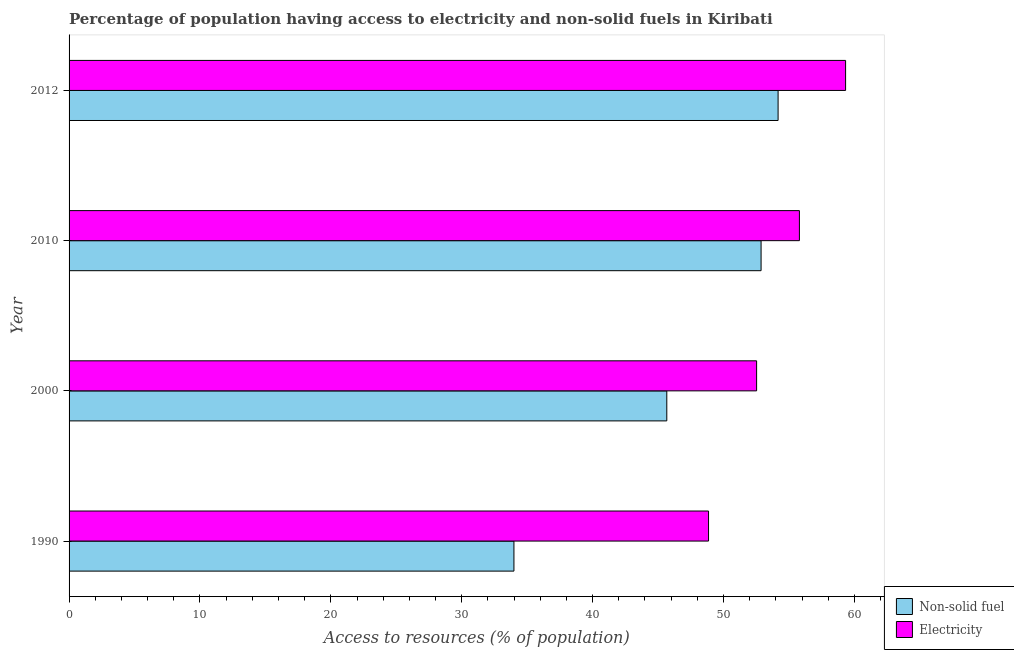How many different coloured bars are there?
Keep it short and to the point. 2. Are the number of bars on each tick of the Y-axis equal?
Ensure brevity in your answer.  Yes. How many bars are there on the 1st tick from the top?
Your response must be concise. 2. What is the label of the 2nd group of bars from the top?
Provide a succinct answer. 2010. What is the percentage of population having access to electricity in 1990?
Give a very brief answer. 48.86. Across all years, what is the maximum percentage of population having access to electricity?
Provide a short and direct response. 59.33. Across all years, what is the minimum percentage of population having access to non-solid fuel?
Your answer should be compact. 33.99. In which year was the percentage of population having access to non-solid fuel minimum?
Ensure brevity in your answer.  1990. What is the total percentage of population having access to non-solid fuel in the graph?
Provide a succinct answer. 186.7. What is the difference between the percentage of population having access to electricity in 1990 and that in 2000?
Provide a succinct answer. -3.67. What is the difference between the percentage of population having access to non-solid fuel in 2000 and the percentage of population having access to electricity in 2010?
Your response must be concise. -10.13. What is the average percentage of population having access to non-solid fuel per year?
Make the answer very short. 46.68. In the year 2012, what is the difference between the percentage of population having access to non-solid fuel and percentage of population having access to electricity?
Offer a very short reply. -5.16. What is the ratio of the percentage of population having access to electricity in 1990 to that in 2012?
Make the answer very short. 0.82. Is the difference between the percentage of population having access to electricity in 2000 and 2010 greater than the difference between the percentage of population having access to non-solid fuel in 2000 and 2010?
Provide a succinct answer. Yes. What is the difference between the highest and the second highest percentage of population having access to non-solid fuel?
Provide a short and direct response. 1.3. What is the difference between the highest and the lowest percentage of population having access to electricity?
Offer a terse response. 10.47. What does the 2nd bar from the top in 1990 represents?
Your answer should be very brief. Non-solid fuel. What does the 2nd bar from the bottom in 2010 represents?
Provide a succinct answer. Electricity. How many years are there in the graph?
Make the answer very short. 4. What is the difference between two consecutive major ticks on the X-axis?
Ensure brevity in your answer.  10. Does the graph contain any zero values?
Provide a succinct answer. No. Where does the legend appear in the graph?
Keep it short and to the point. Bottom right. How many legend labels are there?
Provide a succinct answer. 2. How are the legend labels stacked?
Your response must be concise. Vertical. What is the title of the graph?
Your response must be concise. Percentage of population having access to electricity and non-solid fuels in Kiribati. Does "% of gross capital formation" appear as one of the legend labels in the graph?
Provide a succinct answer. No. What is the label or title of the X-axis?
Give a very brief answer. Access to resources (% of population). What is the label or title of the Y-axis?
Offer a terse response. Year. What is the Access to resources (% of population) of Non-solid fuel in 1990?
Keep it short and to the point. 33.99. What is the Access to resources (% of population) in Electricity in 1990?
Provide a succinct answer. 48.86. What is the Access to resources (% of population) of Non-solid fuel in 2000?
Provide a succinct answer. 45.67. What is the Access to resources (% of population) of Electricity in 2000?
Ensure brevity in your answer.  52.53. What is the Access to resources (% of population) in Non-solid fuel in 2010?
Your response must be concise. 52.87. What is the Access to resources (% of population) of Electricity in 2010?
Make the answer very short. 55.8. What is the Access to resources (% of population) of Non-solid fuel in 2012?
Provide a succinct answer. 54.17. What is the Access to resources (% of population) of Electricity in 2012?
Offer a terse response. 59.33. Across all years, what is the maximum Access to resources (% of population) of Non-solid fuel?
Offer a terse response. 54.17. Across all years, what is the maximum Access to resources (% of population) of Electricity?
Offer a very short reply. 59.33. Across all years, what is the minimum Access to resources (% of population) in Non-solid fuel?
Keep it short and to the point. 33.99. Across all years, what is the minimum Access to resources (% of population) of Electricity?
Provide a short and direct response. 48.86. What is the total Access to resources (% of population) of Non-solid fuel in the graph?
Ensure brevity in your answer.  186.7. What is the total Access to resources (% of population) in Electricity in the graph?
Give a very brief answer. 216.52. What is the difference between the Access to resources (% of population) of Non-solid fuel in 1990 and that in 2000?
Your answer should be very brief. -11.68. What is the difference between the Access to resources (% of population) of Electricity in 1990 and that in 2000?
Your answer should be very brief. -3.67. What is the difference between the Access to resources (% of population) in Non-solid fuel in 1990 and that in 2010?
Your answer should be very brief. -18.88. What is the difference between the Access to resources (% of population) of Electricity in 1990 and that in 2010?
Your response must be concise. -6.94. What is the difference between the Access to resources (% of population) of Non-solid fuel in 1990 and that in 2012?
Ensure brevity in your answer.  -20.18. What is the difference between the Access to resources (% of population) in Electricity in 1990 and that in 2012?
Your answer should be compact. -10.47. What is the difference between the Access to resources (% of population) of Non-solid fuel in 2000 and that in 2010?
Make the answer very short. -7.2. What is the difference between the Access to resources (% of population) in Electricity in 2000 and that in 2010?
Offer a very short reply. -3.27. What is the difference between the Access to resources (% of population) of Non-solid fuel in 2000 and that in 2012?
Keep it short and to the point. -8.5. What is the difference between the Access to resources (% of population) in Electricity in 2000 and that in 2012?
Ensure brevity in your answer.  -6.8. What is the difference between the Access to resources (% of population) in Electricity in 2010 and that in 2012?
Your response must be concise. -3.53. What is the difference between the Access to resources (% of population) in Non-solid fuel in 1990 and the Access to resources (% of population) in Electricity in 2000?
Your answer should be compact. -18.54. What is the difference between the Access to resources (% of population) of Non-solid fuel in 1990 and the Access to resources (% of population) of Electricity in 2010?
Offer a terse response. -21.81. What is the difference between the Access to resources (% of population) in Non-solid fuel in 1990 and the Access to resources (% of population) in Electricity in 2012?
Your answer should be compact. -25.34. What is the difference between the Access to resources (% of population) of Non-solid fuel in 2000 and the Access to resources (% of population) of Electricity in 2010?
Offer a terse response. -10.13. What is the difference between the Access to resources (% of population) in Non-solid fuel in 2000 and the Access to resources (% of population) in Electricity in 2012?
Offer a terse response. -13.66. What is the difference between the Access to resources (% of population) of Non-solid fuel in 2010 and the Access to resources (% of population) of Electricity in 2012?
Provide a succinct answer. -6.46. What is the average Access to resources (% of population) of Non-solid fuel per year?
Provide a succinct answer. 46.68. What is the average Access to resources (% of population) of Electricity per year?
Your answer should be compact. 54.13. In the year 1990, what is the difference between the Access to resources (% of population) in Non-solid fuel and Access to resources (% of population) in Electricity?
Provide a succinct answer. -14.87. In the year 2000, what is the difference between the Access to resources (% of population) in Non-solid fuel and Access to resources (% of population) in Electricity?
Ensure brevity in your answer.  -6.86. In the year 2010, what is the difference between the Access to resources (% of population) in Non-solid fuel and Access to resources (% of population) in Electricity?
Your answer should be compact. -2.93. In the year 2012, what is the difference between the Access to resources (% of population) in Non-solid fuel and Access to resources (% of population) in Electricity?
Provide a succinct answer. -5.16. What is the ratio of the Access to resources (% of population) of Non-solid fuel in 1990 to that in 2000?
Your answer should be compact. 0.74. What is the ratio of the Access to resources (% of population) of Electricity in 1990 to that in 2000?
Your answer should be compact. 0.93. What is the ratio of the Access to resources (% of population) in Non-solid fuel in 1990 to that in 2010?
Make the answer very short. 0.64. What is the ratio of the Access to resources (% of population) of Electricity in 1990 to that in 2010?
Provide a short and direct response. 0.88. What is the ratio of the Access to resources (% of population) of Non-solid fuel in 1990 to that in 2012?
Provide a short and direct response. 0.63. What is the ratio of the Access to resources (% of population) in Electricity in 1990 to that in 2012?
Your answer should be compact. 0.82. What is the ratio of the Access to resources (% of population) of Non-solid fuel in 2000 to that in 2010?
Your answer should be compact. 0.86. What is the ratio of the Access to resources (% of population) in Electricity in 2000 to that in 2010?
Offer a very short reply. 0.94. What is the ratio of the Access to resources (% of population) in Non-solid fuel in 2000 to that in 2012?
Make the answer very short. 0.84. What is the ratio of the Access to resources (% of population) in Electricity in 2000 to that in 2012?
Make the answer very short. 0.89. What is the ratio of the Access to resources (% of population) in Non-solid fuel in 2010 to that in 2012?
Offer a terse response. 0.98. What is the ratio of the Access to resources (% of population) of Electricity in 2010 to that in 2012?
Make the answer very short. 0.94. What is the difference between the highest and the second highest Access to resources (% of population) of Non-solid fuel?
Your answer should be compact. 1.3. What is the difference between the highest and the second highest Access to resources (% of population) in Electricity?
Keep it short and to the point. 3.53. What is the difference between the highest and the lowest Access to resources (% of population) in Non-solid fuel?
Give a very brief answer. 20.18. What is the difference between the highest and the lowest Access to resources (% of population) in Electricity?
Your response must be concise. 10.47. 